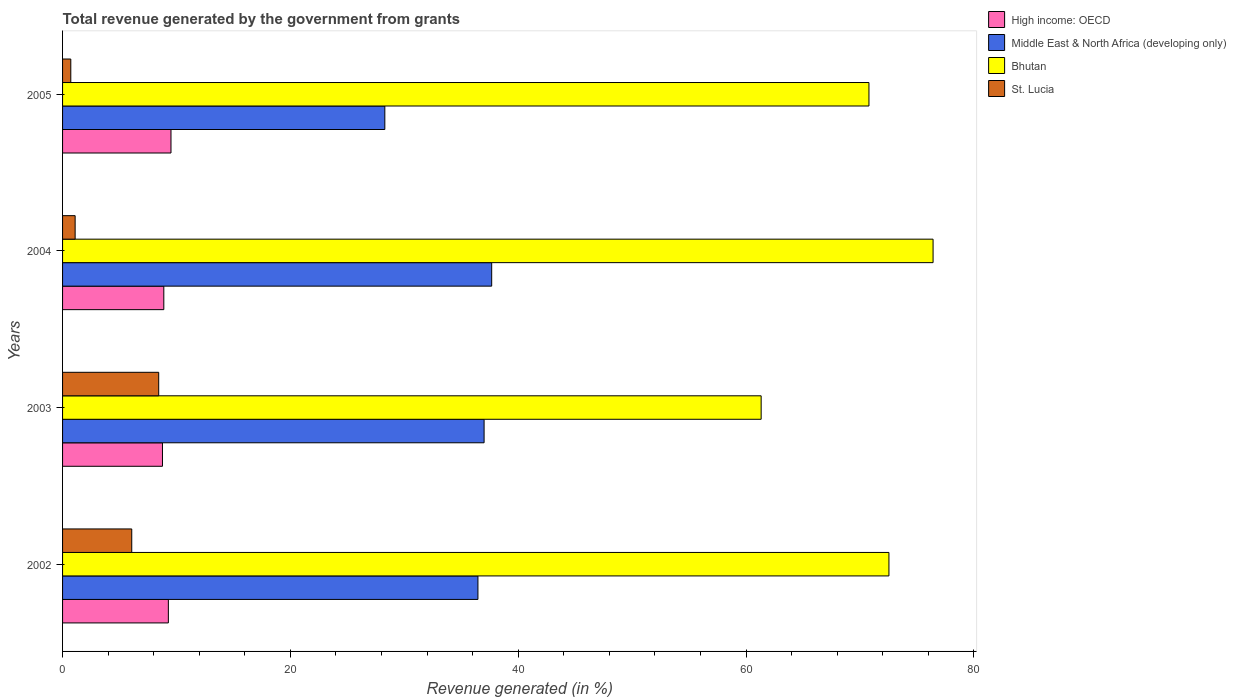How many different coloured bars are there?
Provide a succinct answer. 4. Are the number of bars on each tick of the Y-axis equal?
Make the answer very short. Yes. In how many cases, is the number of bars for a given year not equal to the number of legend labels?
Your response must be concise. 0. What is the total revenue generated in Middle East & North Africa (developing only) in 2004?
Your answer should be compact. 37.67. Across all years, what is the maximum total revenue generated in St. Lucia?
Ensure brevity in your answer.  8.44. Across all years, what is the minimum total revenue generated in High income: OECD?
Ensure brevity in your answer.  8.77. In which year was the total revenue generated in Bhutan maximum?
Offer a terse response. 2004. What is the total total revenue generated in High income: OECD in the graph?
Ensure brevity in your answer.  36.46. What is the difference between the total revenue generated in High income: OECD in 2003 and that in 2004?
Provide a short and direct response. -0.12. What is the difference between the total revenue generated in Middle East & North Africa (developing only) in 2005 and the total revenue generated in High income: OECD in 2003?
Give a very brief answer. 19.52. What is the average total revenue generated in St. Lucia per year?
Offer a very short reply. 4.08. In the year 2004, what is the difference between the total revenue generated in High income: OECD and total revenue generated in St. Lucia?
Your answer should be compact. 7.78. What is the ratio of the total revenue generated in St. Lucia in 2003 to that in 2005?
Offer a very short reply. 11.67. Is the total revenue generated in High income: OECD in 2003 less than that in 2004?
Provide a short and direct response. Yes. What is the difference between the highest and the second highest total revenue generated in Bhutan?
Make the answer very short. 3.87. What is the difference between the highest and the lowest total revenue generated in High income: OECD?
Offer a terse response. 0.75. In how many years, is the total revenue generated in High income: OECD greater than the average total revenue generated in High income: OECD taken over all years?
Offer a terse response. 2. Is the sum of the total revenue generated in Middle East & North Africa (developing only) in 2003 and 2004 greater than the maximum total revenue generated in High income: OECD across all years?
Offer a terse response. Yes. Is it the case that in every year, the sum of the total revenue generated in St. Lucia and total revenue generated in High income: OECD is greater than the sum of total revenue generated in Middle East & North Africa (developing only) and total revenue generated in Bhutan?
Your response must be concise. No. What does the 3rd bar from the top in 2002 represents?
Your answer should be compact. Middle East & North Africa (developing only). What does the 1st bar from the bottom in 2003 represents?
Your answer should be very brief. High income: OECD. How many bars are there?
Give a very brief answer. 16. Are the values on the major ticks of X-axis written in scientific E-notation?
Give a very brief answer. No. Does the graph contain grids?
Offer a very short reply. No. How many legend labels are there?
Keep it short and to the point. 4. What is the title of the graph?
Offer a terse response. Total revenue generated by the government from grants. What is the label or title of the X-axis?
Offer a very short reply. Revenue generated (in %). What is the Revenue generated (in %) in High income: OECD in 2002?
Your answer should be compact. 9.29. What is the Revenue generated (in %) in Middle East & North Africa (developing only) in 2002?
Your answer should be very brief. 36.46. What is the Revenue generated (in %) of Bhutan in 2002?
Keep it short and to the point. 72.54. What is the Revenue generated (in %) in St. Lucia in 2002?
Offer a very short reply. 6.07. What is the Revenue generated (in %) in High income: OECD in 2003?
Your answer should be compact. 8.77. What is the Revenue generated (in %) of Middle East & North Africa (developing only) in 2003?
Offer a terse response. 37. What is the Revenue generated (in %) of Bhutan in 2003?
Your answer should be very brief. 61.32. What is the Revenue generated (in %) of St. Lucia in 2003?
Make the answer very short. 8.44. What is the Revenue generated (in %) in High income: OECD in 2004?
Make the answer very short. 8.89. What is the Revenue generated (in %) in Middle East & North Africa (developing only) in 2004?
Keep it short and to the point. 37.67. What is the Revenue generated (in %) of Bhutan in 2004?
Ensure brevity in your answer.  76.41. What is the Revenue generated (in %) in St. Lucia in 2004?
Your response must be concise. 1.1. What is the Revenue generated (in %) of High income: OECD in 2005?
Make the answer very short. 9.52. What is the Revenue generated (in %) of Middle East & North Africa (developing only) in 2005?
Your answer should be very brief. 28.29. What is the Revenue generated (in %) in Bhutan in 2005?
Your answer should be compact. 70.78. What is the Revenue generated (in %) in St. Lucia in 2005?
Your answer should be very brief. 0.72. Across all years, what is the maximum Revenue generated (in %) of High income: OECD?
Your answer should be very brief. 9.52. Across all years, what is the maximum Revenue generated (in %) of Middle East & North Africa (developing only)?
Your answer should be very brief. 37.67. Across all years, what is the maximum Revenue generated (in %) in Bhutan?
Your answer should be very brief. 76.41. Across all years, what is the maximum Revenue generated (in %) in St. Lucia?
Your answer should be very brief. 8.44. Across all years, what is the minimum Revenue generated (in %) in High income: OECD?
Make the answer very short. 8.77. Across all years, what is the minimum Revenue generated (in %) of Middle East & North Africa (developing only)?
Keep it short and to the point. 28.29. Across all years, what is the minimum Revenue generated (in %) of Bhutan?
Provide a short and direct response. 61.32. Across all years, what is the minimum Revenue generated (in %) of St. Lucia?
Make the answer very short. 0.72. What is the total Revenue generated (in %) of High income: OECD in the graph?
Make the answer very short. 36.46. What is the total Revenue generated (in %) of Middle East & North Africa (developing only) in the graph?
Give a very brief answer. 139.41. What is the total Revenue generated (in %) of Bhutan in the graph?
Your answer should be very brief. 281.05. What is the total Revenue generated (in %) in St. Lucia in the graph?
Keep it short and to the point. 16.34. What is the difference between the Revenue generated (in %) of High income: OECD in 2002 and that in 2003?
Your answer should be compact. 0.52. What is the difference between the Revenue generated (in %) in Middle East & North Africa (developing only) in 2002 and that in 2003?
Your answer should be very brief. -0.54. What is the difference between the Revenue generated (in %) of Bhutan in 2002 and that in 2003?
Your answer should be very brief. 11.22. What is the difference between the Revenue generated (in %) of St. Lucia in 2002 and that in 2003?
Give a very brief answer. -2.36. What is the difference between the Revenue generated (in %) in High income: OECD in 2002 and that in 2004?
Provide a short and direct response. 0.4. What is the difference between the Revenue generated (in %) of Middle East & North Africa (developing only) in 2002 and that in 2004?
Provide a succinct answer. -1.21. What is the difference between the Revenue generated (in %) in Bhutan in 2002 and that in 2004?
Your answer should be very brief. -3.87. What is the difference between the Revenue generated (in %) in St. Lucia in 2002 and that in 2004?
Ensure brevity in your answer.  4.97. What is the difference between the Revenue generated (in %) of High income: OECD in 2002 and that in 2005?
Keep it short and to the point. -0.23. What is the difference between the Revenue generated (in %) in Middle East & North Africa (developing only) in 2002 and that in 2005?
Offer a terse response. 8.17. What is the difference between the Revenue generated (in %) in Bhutan in 2002 and that in 2005?
Your response must be concise. 1.75. What is the difference between the Revenue generated (in %) of St. Lucia in 2002 and that in 2005?
Offer a very short reply. 5.35. What is the difference between the Revenue generated (in %) of High income: OECD in 2003 and that in 2004?
Your response must be concise. -0.12. What is the difference between the Revenue generated (in %) of Middle East & North Africa (developing only) in 2003 and that in 2004?
Make the answer very short. -0.67. What is the difference between the Revenue generated (in %) of Bhutan in 2003 and that in 2004?
Your answer should be compact. -15.09. What is the difference between the Revenue generated (in %) of St. Lucia in 2003 and that in 2004?
Make the answer very short. 7.33. What is the difference between the Revenue generated (in %) in High income: OECD in 2003 and that in 2005?
Your response must be concise. -0.75. What is the difference between the Revenue generated (in %) in Middle East & North Africa (developing only) in 2003 and that in 2005?
Your answer should be compact. 8.71. What is the difference between the Revenue generated (in %) of Bhutan in 2003 and that in 2005?
Provide a short and direct response. -9.46. What is the difference between the Revenue generated (in %) in St. Lucia in 2003 and that in 2005?
Your response must be concise. 7.72. What is the difference between the Revenue generated (in %) of High income: OECD in 2004 and that in 2005?
Give a very brief answer. -0.63. What is the difference between the Revenue generated (in %) in Middle East & North Africa (developing only) in 2004 and that in 2005?
Offer a terse response. 9.38. What is the difference between the Revenue generated (in %) of Bhutan in 2004 and that in 2005?
Offer a very short reply. 5.63. What is the difference between the Revenue generated (in %) of St. Lucia in 2004 and that in 2005?
Your answer should be compact. 0.38. What is the difference between the Revenue generated (in %) of High income: OECD in 2002 and the Revenue generated (in %) of Middle East & North Africa (developing only) in 2003?
Your response must be concise. -27.71. What is the difference between the Revenue generated (in %) of High income: OECD in 2002 and the Revenue generated (in %) of Bhutan in 2003?
Give a very brief answer. -52.03. What is the difference between the Revenue generated (in %) in High income: OECD in 2002 and the Revenue generated (in %) in St. Lucia in 2003?
Keep it short and to the point. 0.85. What is the difference between the Revenue generated (in %) in Middle East & North Africa (developing only) in 2002 and the Revenue generated (in %) in Bhutan in 2003?
Your response must be concise. -24.86. What is the difference between the Revenue generated (in %) of Middle East & North Africa (developing only) in 2002 and the Revenue generated (in %) of St. Lucia in 2003?
Make the answer very short. 28.02. What is the difference between the Revenue generated (in %) in Bhutan in 2002 and the Revenue generated (in %) in St. Lucia in 2003?
Ensure brevity in your answer.  64.1. What is the difference between the Revenue generated (in %) of High income: OECD in 2002 and the Revenue generated (in %) of Middle East & North Africa (developing only) in 2004?
Your answer should be very brief. -28.38. What is the difference between the Revenue generated (in %) in High income: OECD in 2002 and the Revenue generated (in %) in Bhutan in 2004?
Keep it short and to the point. -67.12. What is the difference between the Revenue generated (in %) in High income: OECD in 2002 and the Revenue generated (in %) in St. Lucia in 2004?
Ensure brevity in your answer.  8.18. What is the difference between the Revenue generated (in %) of Middle East & North Africa (developing only) in 2002 and the Revenue generated (in %) of Bhutan in 2004?
Offer a very short reply. -39.95. What is the difference between the Revenue generated (in %) in Middle East & North Africa (developing only) in 2002 and the Revenue generated (in %) in St. Lucia in 2004?
Provide a succinct answer. 35.36. What is the difference between the Revenue generated (in %) of Bhutan in 2002 and the Revenue generated (in %) of St. Lucia in 2004?
Keep it short and to the point. 71.43. What is the difference between the Revenue generated (in %) in High income: OECD in 2002 and the Revenue generated (in %) in Middle East & North Africa (developing only) in 2005?
Provide a succinct answer. -19. What is the difference between the Revenue generated (in %) in High income: OECD in 2002 and the Revenue generated (in %) in Bhutan in 2005?
Provide a succinct answer. -61.5. What is the difference between the Revenue generated (in %) of High income: OECD in 2002 and the Revenue generated (in %) of St. Lucia in 2005?
Provide a short and direct response. 8.56. What is the difference between the Revenue generated (in %) in Middle East & North Africa (developing only) in 2002 and the Revenue generated (in %) in Bhutan in 2005?
Make the answer very short. -34.32. What is the difference between the Revenue generated (in %) in Middle East & North Africa (developing only) in 2002 and the Revenue generated (in %) in St. Lucia in 2005?
Offer a very short reply. 35.74. What is the difference between the Revenue generated (in %) in Bhutan in 2002 and the Revenue generated (in %) in St. Lucia in 2005?
Keep it short and to the point. 71.81. What is the difference between the Revenue generated (in %) in High income: OECD in 2003 and the Revenue generated (in %) in Middle East & North Africa (developing only) in 2004?
Your answer should be very brief. -28.9. What is the difference between the Revenue generated (in %) in High income: OECD in 2003 and the Revenue generated (in %) in Bhutan in 2004?
Offer a very short reply. -67.64. What is the difference between the Revenue generated (in %) of High income: OECD in 2003 and the Revenue generated (in %) of St. Lucia in 2004?
Your answer should be very brief. 7.67. What is the difference between the Revenue generated (in %) of Middle East & North Africa (developing only) in 2003 and the Revenue generated (in %) of Bhutan in 2004?
Keep it short and to the point. -39.41. What is the difference between the Revenue generated (in %) of Middle East & North Africa (developing only) in 2003 and the Revenue generated (in %) of St. Lucia in 2004?
Give a very brief answer. 35.9. What is the difference between the Revenue generated (in %) of Bhutan in 2003 and the Revenue generated (in %) of St. Lucia in 2004?
Give a very brief answer. 60.22. What is the difference between the Revenue generated (in %) of High income: OECD in 2003 and the Revenue generated (in %) of Middle East & North Africa (developing only) in 2005?
Provide a succinct answer. -19.52. What is the difference between the Revenue generated (in %) in High income: OECD in 2003 and the Revenue generated (in %) in Bhutan in 2005?
Offer a very short reply. -62.01. What is the difference between the Revenue generated (in %) in High income: OECD in 2003 and the Revenue generated (in %) in St. Lucia in 2005?
Offer a terse response. 8.05. What is the difference between the Revenue generated (in %) of Middle East & North Africa (developing only) in 2003 and the Revenue generated (in %) of Bhutan in 2005?
Your answer should be compact. -33.78. What is the difference between the Revenue generated (in %) in Middle East & North Africa (developing only) in 2003 and the Revenue generated (in %) in St. Lucia in 2005?
Make the answer very short. 36.28. What is the difference between the Revenue generated (in %) in Bhutan in 2003 and the Revenue generated (in %) in St. Lucia in 2005?
Provide a succinct answer. 60.6. What is the difference between the Revenue generated (in %) in High income: OECD in 2004 and the Revenue generated (in %) in Middle East & North Africa (developing only) in 2005?
Your response must be concise. -19.4. What is the difference between the Revenue generated (in %) in High income: OECD in 2004 and the Revenue generated (in %) in Bhutan in 2005?
Give a very brief answer. -61.9. What is the difference between the Revenue generated (in %) in High income: OECD in 2004 and the Revenue generated (in %) in St. Lucia in 2005?
Your response must be concise. 8.16. What is the difference between the Revenue generated (in %) in Middle East & North Africa (developing only) in 2004 and the Revenue generated (in %) in Bhutan in 2005?
Your answer should be compact. -33.12. What is the difference between the Revenue generated (in %) of Middle East & North Africa (developing only) in 2004 and the Revenue generated (in %) of St. Lucia in 2005?
Keep it short and to the point. 36.94. What is the difference between the Revenue generated (in %) in Bhutan in 2004 and the Revenue generated (in %) in St. Lucia in 2005?
Provide a succinct answer. 75.69. What is the average Revenue generated (in %) in High income: OECD per year?
Ensure brevity in your answer.  9.11. What is the average Revenue generated (in %) in Middle East & North Africa (developing only) per year?
Ensure brevity in your answer.  34.85. What is the average Revenue generated (in %) in Bhutan per year?
Keep it short and to the point. 70.26. What is the average Revenue generated (in %) in St. Lucia per year?
Your answer should be compact. 4.08. In the year 2002, what is the difference between the Revenue generated (in %) of High income: OECD and Revenue generated (in %) of Middle East & North Africa (developing only)?
Keep it short and to the point. -27.17. In the year 2002, what is the difference between the Revenue generated (in %) in High income: OECD and Revenue generated (in %) in Bhutan?
Ensure brevity in your answer.  -63.25. In the year 2002, what is the difference between the Revenue generated (in %) in High income: OECD and Revenue generated (in %) in St. Lucia?
Keep it short and to the point. 3.21. In the year 2002, what is the difference between the Revenue generated (in %) of Middle East & North Africa (developing only) and Revenue generated (in %) of Bhutan?
Provide a short and direct response. -36.08. In the year 2002, what is the difference between the Revenue generated (in %) in Middle East & North Africa (developing only) and Revenue generated (in %) in St. Lucia?
Offer a very short reply. 30.39. In the year 2002, what is the difference between the Revenue generated (in %) in Bhutan and Revenue generated (in %) in St. Lucia?
Offer a terse response. 66.46. In the year 2003, what is the difference between the Revenue generated (in %) of High income: OECD and Revenue generated (in %) of Middle East & North Africa (developing only)?
Your response must be concise. -28.23. In the year 2003, what is the difference between the Revenue generated (in %) of High income: OECD and Revenue generated (in %) of Bhutan?
Offer a terse response. -52.55. In the year 2003, what is the difference between the Revenue generated (in %) in High income: OECD and Revenue generated (in %) in St. Lucia?
Give a very brief answer. 0.33. In the year 2003, what is the difference between the Revenue generated (in %) of Middle East & North Africa (developing only) and Revenue generated (in %) of Bhutan?
Offer a very short reply. -24.32. In the year 2003, what is the difference between the Revenue generated (in %) of Middle East & North Africa (developing only) and Revenue generated (in %) of St. Lucia?
Provide a short and direct response. 28.56. In the year 2003, what is the difference between the Revenue generated (in %) in Bhutan and Revenue generated (in %) in St. Lucia?
Provide a short and direct response. 52.88. In the year 2004, what is the difference between the Revenue generated (in %) in High income: OECD and Revenue generated (in %) in Middle East & North Africa (developing only)?
Give a very brief answer. -28.78. In the year 2004, what is the difference between the Revenue generated (in %) of High income: OECD and Revenue generated (in %) of Bhutan?
Give a very brief answer. -67.52. In the year 2004, what is the difference between the Revenue generated (in %) of High income: OECD and Revenue generated (in %) of St. Lucia?
Provide a short and direct response. 7.78. In the year 2004, what is the difference between the Revenue generated (in %) in Middle East & North Africa (developing only) and Revenue generated (in %) in Bhutan?
Your answer should be very brief. -38.74. In the year 2004, what is the difference between the Revenue generated (in %) in Middle East & North Africa (developing only) and Revenue generated (in %) in St. Lucia?
Offer a terse response. 36.56. In the year 2004, what is the difference between the Revenue generated (in %) of Bhutan and Revenue generated (in %) of St. Lucia?
Your answer should be compact. 75.31. In the year 2005, what is the difference between the Revenue generated (in %) of High income: OECD and Revenue generated (in %) of Middle East & North Africa (developing only)?
Provide a short and direct response. -18.77. In the year 2005, what is the difference between the Revenue generated (in %) of High income: OECD and Revenue generated (in %) of Bhutan?
Your answer should be very brief. -61.26. In the year 2005, what is the difference between the Revenue generated (in %) in High income: OECD and Revenue generated (in %) in St. Lucia?
Make the answer very short. 8.79. In the year 2005, what is the difference between the Revenue generated (in %) of Middle East & North Africa (developing only) and Revenue generated (in %) of Bhutan?
Give a very brief answer. -42.5. In the year 2005, what is the difference between the Revenue generated (in %) of Middle East & North Africa (developing only) and Revenue generated (in %) of St. Lucia?
Your response must be concise. 27.56. In the year 2005, what is the difference between the Revenue generated (in %) in Bhutan and Revenue generated (in %) in St. Lucia?
Your answer should be compact. 70.06. What is the ratio of the Revenue generated (in %) of High income: OECD in 2002 to that in 2003?
Your response must be concise. 1.06. What is the ratio of the Revenue generated (in %) in Middle East & North Africa (developing only) in 2002 to that in 2003?
Offer a terse response. 0.99. What is the ratio of the Revenue generated (in %) in Bhutan in 2002 to that in 2003?
Your answer should be very brief. 1.18. What is the ratio of the Revenue generated (in %) of St. Lucia in 2002 to that in 2003?
Give a very brief answer. 0.72. What is the ratio of the Revenue generated (in %) in High income: OECD in 2002 to that in 2004?
Give a very brief answer. 1.04. What is the ratio of the Revenue generated (in %) in Middle East & North Africa (developing only) in 2002 to that in 2004?
Make the answer very short. 0.97. What is the ratio of the Revenue generated (in %) in Bhutan in 2002 to that in 2004?
Your response must be concise. 0.95. What is the ratio of the Revenue generated (in %) of St. Lucia in 2002 to that in 2004?
Provide a succinct answer. 5.51. What is the ratio of the Revenue generated (in %) in High income: OECD in 2002 to that in 2005?
Give a very brief answer. 0.98. What is the ratio of the Revenue generated (in %) of Middle East & North Africa (developing only) in 2002 to that in 2005?
Provide a succinct answer. 1.29. What is the ratio of the Revenue generated (in %) of Bhutan in 2002 to that in 2005?
Your answer should be compact. 1.02. What is the ratio of the Revenue generated (in %) in St. Lucia in 2002 to that in 2005?
Ensure brevity in your answer.  8.4. What is the ratio of the Revenue generated (in %) in High income: OECD in 2003 to that in 2004?
Give a very brief answer. 0.99. What is the ratio of the Revenue generated (in %) of Middle East & North Africa (developing only) in 2003 to that in 2004?
Make the answer very short. 0.98. What is the ratio of the Revenue generated (in %) in Bhutan in 2003 to that in 2004?
Offer a very short reply. 0.8. What is the ratio of the Revenue generated (in %) in St. Lucia in 2003 to that in 2004?
Ensure brevity in your answer.  7.65. What is the ratio of the Revenue generated (in %) of High income: OECD in 2003 to that in 2005?
Keep it short and to the point. 0.92. What is the ratio of the Revenue generated (in %) of Middle East & North Africa (developing only) in 2003 to that in 2005?
Your response must be concise. 1.31. What is the ratio of the Revenue generated (in %) in Bhutan in 2003 to that in 2005?
Ensure brevity in your answer.  0.87. What is the ratio of the Revenue generated (in %) in St. Lucia in 2003 to that in 2005?
Provide a succinct answer. 11.67. What is the ratio of the Revenue generated (in %) in High income: OECD in 2004 to that in 2005?
Make the answer very short. 0.93. What is the ratio of the Revenue generated (in %) in Middle East & North Africa (developing only) in 2004 to that in 2005?
Your answer should be very brief. 1.33. What is the ratio of the Revenue generated (in %) in Bhutan in 2004 to that in 2005?
Offer a terse response. 1.08. What is the ratio of the Revenue generated (in %) in St. Lucia in 2004 to that in 2005?
Give a very brief answer. 1.53. What is the difference between the highest and the second highest Revenue generated (in %) in High income: OECD?
Provide a succinct answer. 0.23. What is the difference between the highest and the second highest Revenue generated (in %) of Middle East & North Africa (developing only)?
Offer a very short reply. 0.67. What is the difference between the highest and the second highest Revenue generated (in %) in Bhutan?
Provide a succinct answer. 3.87. What is the difference between the highest and the second highest Revenue generated (in %) in St. Lucia?
Your answer should be very brief. 2.36. What is the difference between the highest and the lowest Revenue generated (in %) in High income: OECD?
Give a very brief answer. 0.75. What is the difference between the highest and the lowest Revenue generated (in %) of Middle East & North Africa (developing only)?
Give a very brief answer. 9.38. What is the difference between the highest and the lowest Revenue generated (in %) in Bhutan?
Provide a succinct answer. 15.09. What is the difference between the highest and the lowest Revenue generated (in %) of St. Lucia?
Keep it short and to the point. 7.72. 